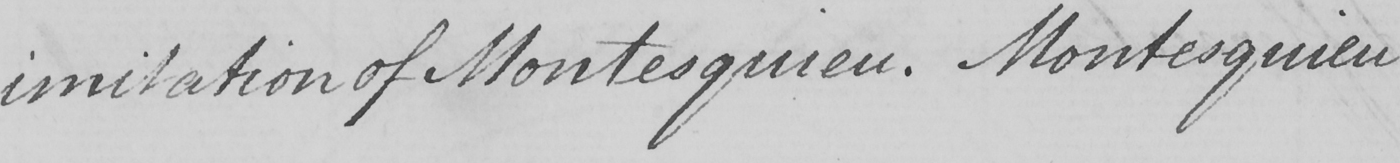What does this handwritten line say? imitation of Montesquieu . Montesquieu 